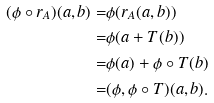<formula> <loc_0><loc_0><loc_500><loc_500>( \phi \circ r _ { A } ) ( a , b ) = & \phi ( r _ { A } ( a , b ) ) \\ = & \phi ( a + T ( b ) ) \\ = & \phi ( a ) + \phi \circ T ( b ) \\ = & ( \phi , \phi \circ T ) ( a , b ) .</formula> 